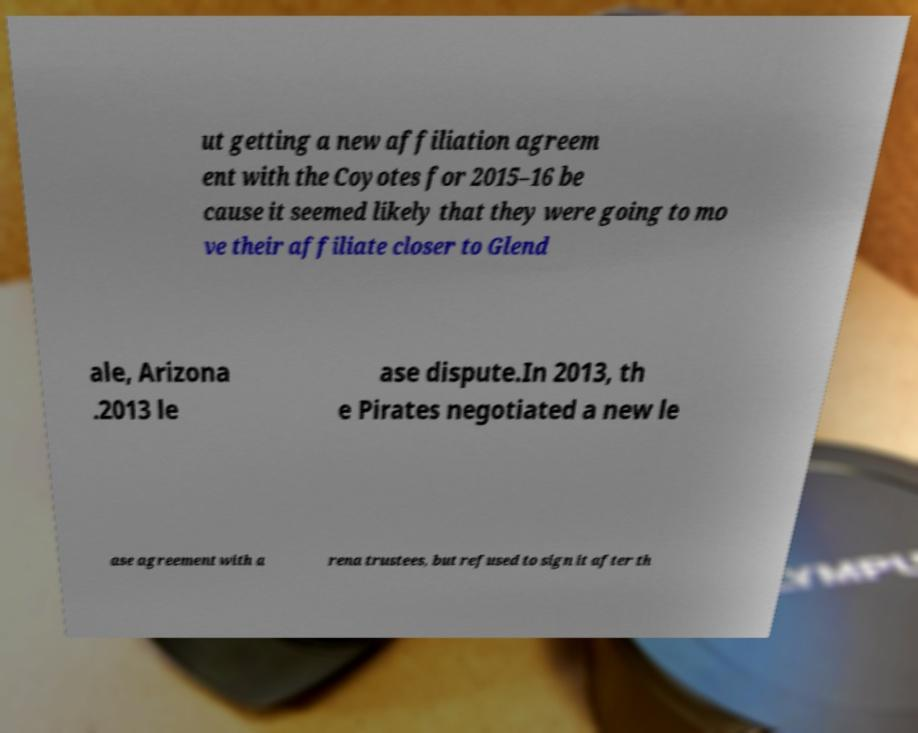Please read and relay the text visible in this image. What does it say? ut getting a new affiliation agreem ent with the Coyotes for 2015–16 be cause it seemed likely that they were going to mo ve their affiliate closer to Glend ale, Arizona .2013 le ase dispute.In 2013, th e Pirates negotiated a new le ase agreement with a rena trustees, but refused to sign it after th 